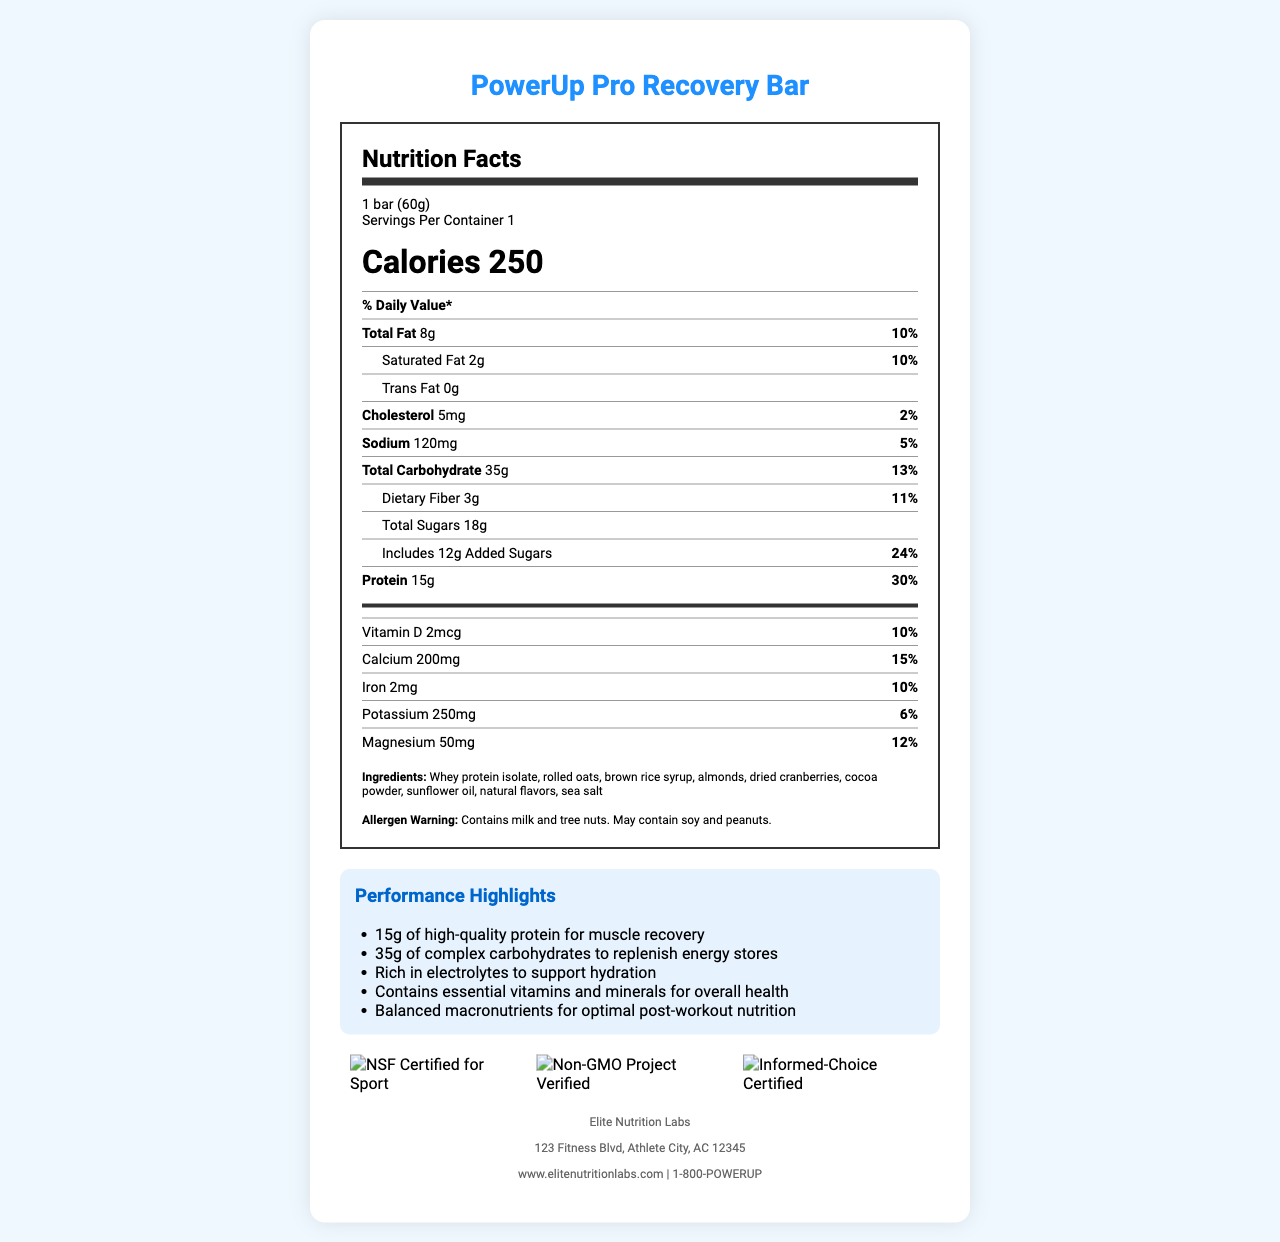what is the serving size of the PowerUp Pro Recovery Bar? The serving size is mentioned directly on the document, listed as "1 bar (60g)".
Answer: 1 bar (60g) how many calories are in each serving? The calories per serving are stated clearly in a large, bold font in the document.
Answer: 250 what is the protein content in the PowerUp Pro Recovery Bar? The protein content is listed as "15g" followed by the percent daily value "%DV" which is 30%.
Answer: 15g what are the total and added sugars in the PowerUp Pro Recovery Bar? The total sugars and added sugars are separated in the nutrition details. Total Sugars show 18g and the added sugars are noted as 12g.
Answer: Total Sugars: 18g, Added Sugars: 12g what is the contact phone number for Elite Nutrition Labs? The manufacturer's contact phone number is listed in the manufacturer information section at the bottom of the document.
Answer: 1-800-POWERUP what certifications does the PowerUp Pro Recovery Bar have? A. Non-GMO Project Verified, NSF Certified for Sport, USDA Organic B. NSF Certified for Sport, Non-GMO Project Verified, Informed-Choice Certified C. Informed-Choice Certified, Non-GMO Project Verified, USDA Organic The document lists the certifications at the bottom, which are NSF Certified for Sport, Non-GMO Project Verified, and Informed-Choice Certified.
Answer: B what percentage of the daily value of calcium does the PowerUp Pro Recovery Bar provide? A. 6% B. 12% C. 15% D. 24% The nutrition facts list Calcium as 200mg, which is noted to be 15% of the daily value.
Answer: C how many servings are in one container? The servings per container are clearly noted as "1" in the serving information section.
Answer: 1 does the PowerUp Pro Recovery Bar contain any allergens? The allergen warning at the bottom states that it contains milk and tree nuts, and may contain soy and peanuts.
Answer: Yes does the PowerUp Pro Recovery Bar support hydration? One of the performance highlights specifically mentions that the bar is "Rich in electrolytes to support hydration".
Answer: Yes summarize the nutrition and performance features of the PowerUp Pro Recovery Bar. The nutrition facts and performance highlights give a comprehensive view of the bar's nutritional content and its intended benefits for athletes post-workout.
Answer: The PowerUp Pro Recovery Bar contains 250 calories per serving with a balanced mix of macronutrients including 15g of protein, 35g of carbohydrates, and 8g of total fat. It's designed to support muscle recovery with high-quality protein and rehydrate the body with electrolytes. The bar is fortified with essential vitamins and minerals and is NSF Certified for Sport, Non-GMO Project Verified, and Informed-Choice Certified. what flavors does the PowerUp Pro Recovery Bar come in? The document lists ingredients but does not provide information on the different flavor options available for the bar.
Answer: Not enough information 